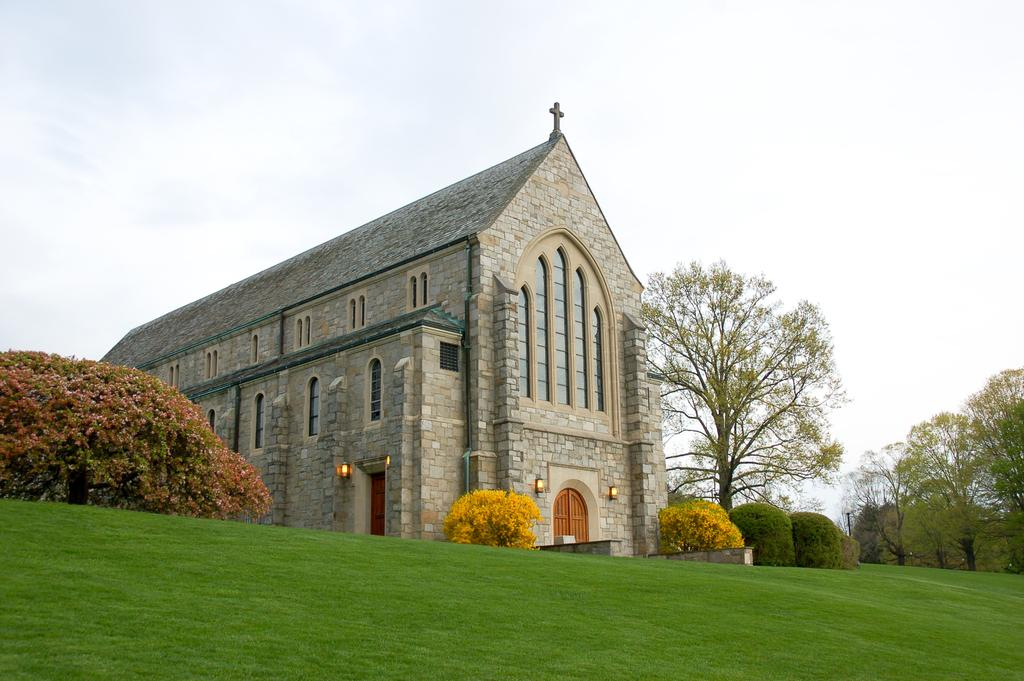What type of building is depicted in the image? The building in the image has a cross on top, which suggests it is a religious building, such as a church. What features of the building are visible in the image? The building has lights and a wooden door. What type of vegetation can be seen in the image? There are garden plants, grass, and trees in the image. How many jellyfish are swimming in the garden plants in the image? There are no jellyfish present in the image; it features a building with a cross on top and garden plants. What type of cart is parked next to the building in the image? There is no cart present in the image; it only features a building with a cross on top, garden plants, grass, and trees. 